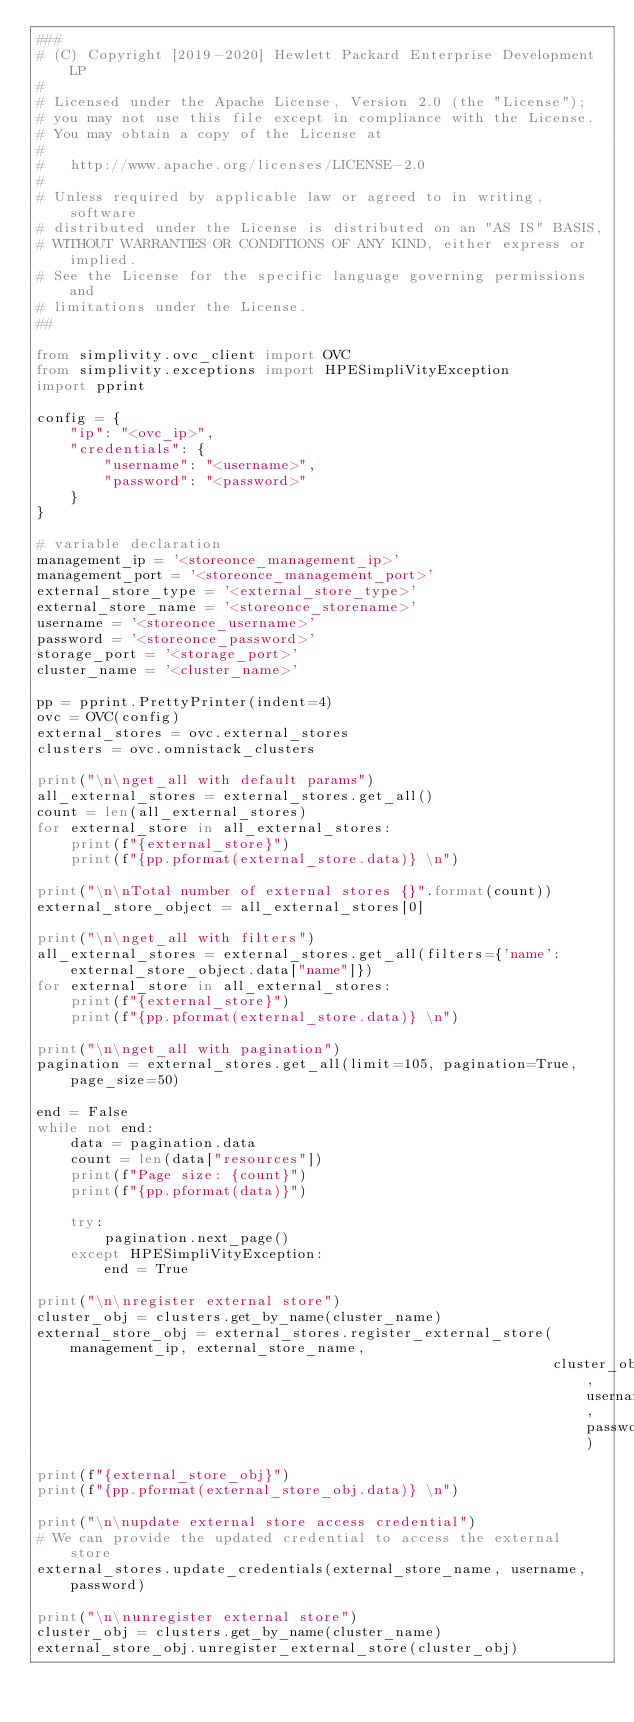Convert code to text. <code><loc_0><loc_0><loc_500><loc_500><_Python_>###
# (C) Copyright [2019-2020] Hewlett Packard Enterprise Development LP
#
# Licensed under the Apache License, Version 2.0 (the "License");
# you may not use this file except in compliance with the License.
# You may obtain a copy of the License at
#
#   http://www.apache.org/licenses/LICENSE-2.0
#
# Unless required by applicable law or agreed to in writing, software
# distributed under the License is distributed on an "AS IS" BASIS,
# WITHOUT WARRANTIES OR CONDITIONS OF ANY KIND, either express or implied.
# See the License for the specific language governing permissions and
# limitations under the License.
##

from simplivity.ovc_client import OVC
from simplivity.exceptions import HPESimpliVityException
import pprint

config = {
    "ip": "<ovc_ip>",
    "credentials": {
        "username": "<username>",
        "password": "<password>"
    }
}

# variable declaration
management_ip = '<storeonce_management_ip>'
management_port = '<storeonce_management_port>'
external_store_type = '<external_store_type>'
external_store_name = '<storeonce_storename>'
username = '<storeonce_username>'
password = '<storeonce_password>'
storage_port = '<storage_port>'
cluster_name = '<cluster_name>'

pp = pprint.PrettyPrinter(indent=4)
ovc = OVC(config)
external_stores = ovc.external_stores
clusters = ovc.omnistack_clusters

print("\n\nget_all with default params")
all_external_stores = external_stores.get_all()
count = len(all_external_stores)
for external_store in all_external_stores:
    print(f"{external_store}")
    print(f"{pp.pformat(external_store.data)} \n")

print("\n\nTotal number of external stores {}".format(count))
external_store_object = all_external_stores[0]

print("\n\nget_all with filters")
all_external_stores = external_stores.get_all(filters={'name': external_store_object.data["name"]})
for external_store in all_external_stores:
    print(f"{external_store}")
    print(f"{pp.pformat(external_store.data)} \n")

print("\n\nget_all with pagination")
pagination = external_stores.get_all(limit=105, pagination=True, page_size=50)

end = False
while not end:
    data = pagination.data
    count = len(data["resources"])
    print(f"Page size: {count}")
    print(f"{pp.pformat(data)}")

    try:
        pagination.next_page()
    except HPESimpliVityException:
        end = True

print("\n\nregister external store")
cluster_obj = clusters.get_by_name(cluster_name)
external_store_obj = external_stores.register_external_store(management_ip, external_store_name,
                                                             cluster_obj, username, password)

print(f"{external_store_obj}")
print(f"{pp.pformat(external_store_obj.data)} \n")

print("\n\nupdate external store access credential")
# We can provide the updated credential to access the external store
external_stores.update_credentials(external_store_name, username, password)

print("\n\nunregister external store")
cluster_obj = clusters.get_by_name(cluster_name)
external_store_obj.unregister_external_store(cluster_obj)
</code> 